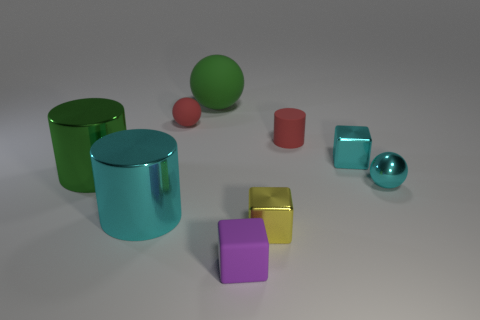What number of other objects are there of the same color as the large matte thing?
Your answer should be very brief. 1. There is another metal object that is the same shape as the yellow thing; what size is it?
Your answer should be compact. Small. Is the number of tiny cyan shiny cubes that are on the left side of the purple matte thing less than the number of yellow things in front of the small cyan ball?
Your answer should be compact. Yes. The rubber object that is on the right side of the green rubber thing and behind the small yellow thing has what shape?
Your answer should be very brief. Cylinder. What is the size of the green object that is the same material as the purple cube?
Give a very brief answer. Large. Do the tiny cylinder and the ball that is in front of the rubber cylinder have the same color?
Your answer should be very brief. No. What is the cyan thing that is in front of the large green cylinder and to the right of the small red rubber sphere made of?
Ensure brevity in your answer.  Metal. There is a rubber cylinder that is the same color as the tiny matte sphere; what is its size?
Offer a very short reply. Small. There is a red thing right of the small matte sphere; is its shape the same as the cyan metallic object that is on the left side of the large green rubber sphere?
Your answer should be compact. Yes. Are there any large yellow matte balls?
Ensure brevity in your answer.  No. 